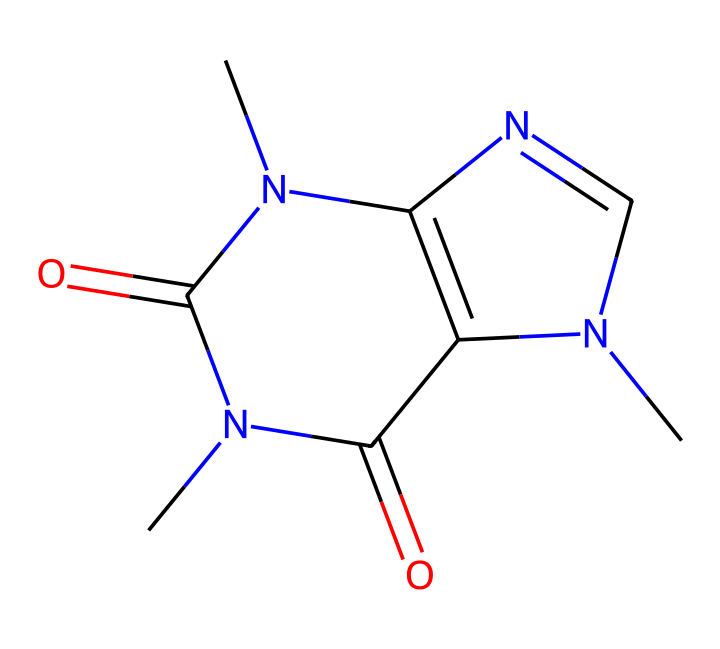What is the molecular formula of this chemical? The molecular formula is derived from counting each type of atom in the structure represented by the SMILES notation. For this chemical, we identify the elements: carbon (C), nitrogen (N), and oxygen (O). Counting the atoms, we find there are 6 carbon atoms, 8 nitrogen atoms, and 4 oxygen atoms, which results in the molecular formula being C8H10N4O2.
Answer: C8H10N4O2 How many rings are present in the structure? Analyzing the SMILES representation, we can see the numeric indicators (like '1' and '2') which denote the start and end of rings. Counting these indicators shows that there are two distinct rings.
Answer: 2 What type of chemical compound is caffeine classified as? Caffeine is classified as an alkaloid based on its structure, particularly due to the presence of multiple nitrogen atoms arranged in a heterocyclic configuration. This classification is typical for compounds that have significant physiological effects.
Answer: alkaloid What functional groups are present in this compound? By examining the SMILES representation, we can identify various functional groups such as amides (due to the carbonyls connected to nitrogen). The presence of carbonyl and nitrogen groups indicates functionalities typical of alkaloids.
Answer: amide How many nitrogen atoms are in the structure? Counting the nitrogen atoms in the SMILES notation reveals that there are four nitrogen atoms present, contributing to the compound's properties as an alkaloid.
Answer: 4 What does the presence of nitrogen suggest about this chemical's effects? The presence of nitrogen in the structure is indicative of biological activity, particularly in alkaloids which often have stimulant effects. In caffeine, this nitrogen contributes to its ability to act as a central nervous system stimulant.
Answer: stimulant 